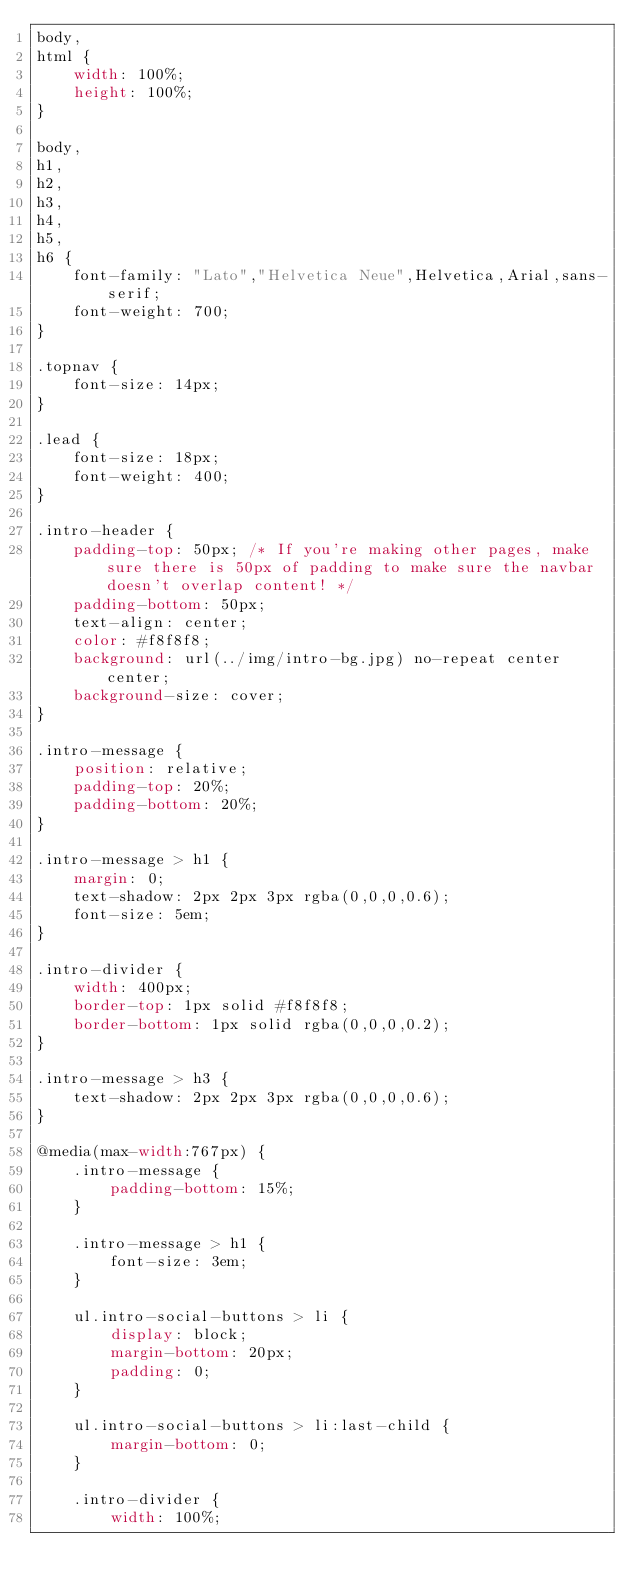<code> <loc_0><loc_0><loc_500><loc_500><_CSS_>body,
html {
    width: 100%;
    height: 100%;
}

body,
h1,
h2,
h3,
h4,
h5,
h6 {
    font-family: "Lato","Helvetica Neue",Helvetica,Arial,sans-serif;
    font-weight: 700;
}

.topnav {
    font-size: 14px;
}

.lead {
    font-size: 18px;
    font-weight: 400;
}

.intro-header {
    padding-top: 50px; /* If you're making other pages, make sure there is 50px of padding to make sure the navbar doesn't overlap content! */
    padding-bottom: 50px;
    text-align: center;
    color: #f8f8f8;
    background: url(../img/intro-bg.jpg) no-repeat center center;
    background-size: cover;
}

.intro-message {
    position: relative;
    padding-top: 20%;
    padding-bottom: 20%;
}

.intro-message > h1 {
    margin: 0;
    text-shadow: 2px 2px 3px rgba(0,0,0,0.6);
    font-size: 5em;
}

.intro-divider {
    width: 400px;
    border-top: 1px solid #f8f8f8;
    border-bottom: 1px solid rgba(0,0,0,0.2);
}

.intro-message > h3 {
    text-shadow: 2px 2px 3px rgba(0,0,0,0.6);
}

@media(max-width:767px) {
    .intro-message {
        padding-bottom: 15%;
    }

    .intro-message > h1 {
        font-size: 3em;
    }

    ul.intro-social-buttons > li {
        display: block;
        margin-bottom: 20px;
        padding: 0;
    }

    ul.intro-social-buttons > li:last-child {
        margin-bottom: 0;
    }

    .intro-divider {
        width: 100%;</code> 